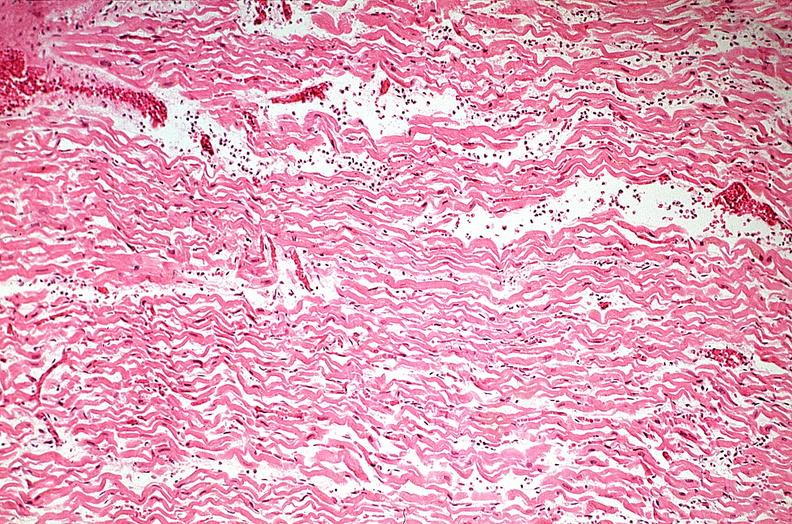s carcinomatosis present?
Answer the question using a single word or phrase. No 